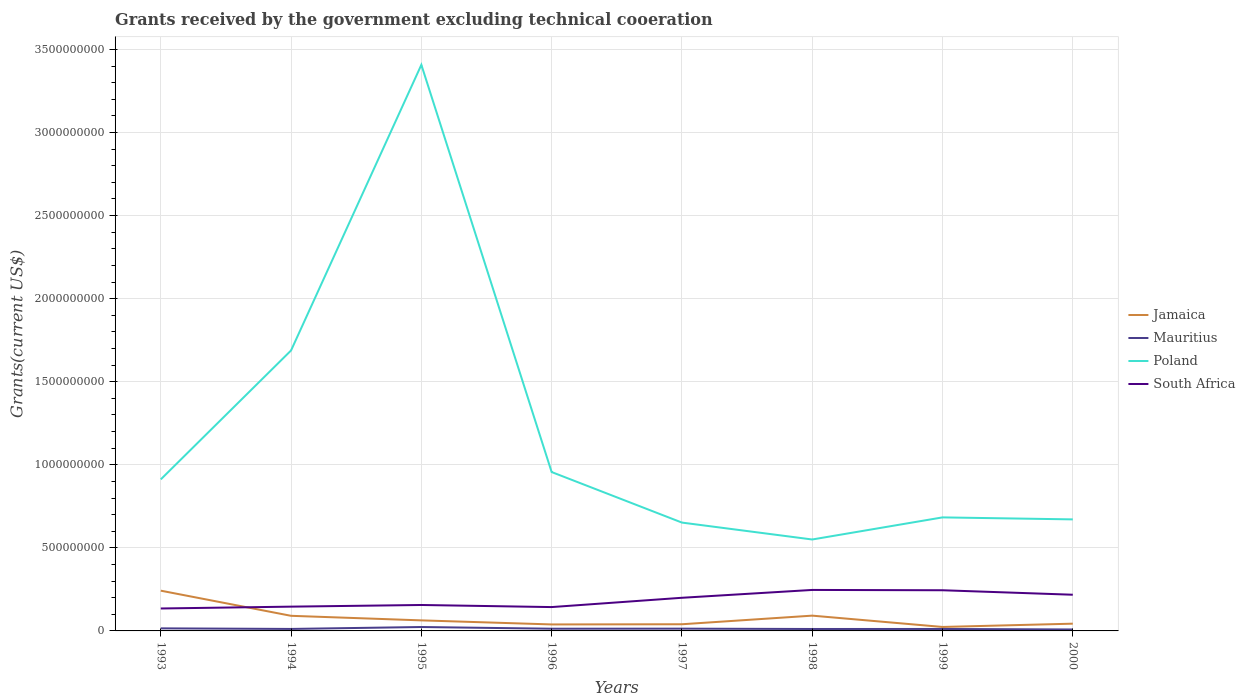How many different coloured lines are there?
Your answer should be very brief. 4. Does the line corresponding to Jamaica intersect with the line corresponding to South Africa?
Offer a very short reply. Yes. Is the number of lines equal to the number of legend labels?
Ensure brevity in your answer.  Yes. Across all years, what is the maximum total grants received by the government in Poland?
Keep it short and to the point. 5.50e+08. In which year was the total grants received by the government in South Africa maximum?
Give a very brief answer. 1993. What is the total total grants received by the government in Poland in the graph?
Offer a very short reply. 2.45e+09. What is the difference between the highest and the second highest total grants received by the government in South Africa?
Ensure brevity in your answer.  1.12e+08. What is the difference between the highest and the lowest total grants received by the government in South Africa?
Your answer should be compact. 4. How many years are there in the graph?
Ensure brevity in your answer.  8. Does the graph contain grids?
Your response must be concise. Yes. Where does the legend appear in the graph?
Make the answer very short. Center right. How many legend labels are there?
Your answer should be compact. 4. How are the legend labels stacked?
Offer a terse response. Vertical. What is the title of the graph?
Your answer should be very brief. Grants received by the government excluding technical cooeration. Does "High income: OECD" appear as one of the legend labels in the graph?
Provide a short and direct response. No. What is the label or title of the X-axis?
Ensure brevity in your answer.  Years. What is the label or title of the Y-axis?
Provide a succinct answer. Grants(current US$). What is the Grants(current US$) of Jamaica in 1993?
Provide a succinct answer. 2.42e+08. What is the Grants(current US$) in Mauritius in 1993?
Ensure brevity in your answer.  1.54e+07. What is the Grants(current US$) in Poland in 1993?
Your response must be concise. 9.12e+08. What is the Grants(current US$) in South Africa in 1993?
Provide a short and direct response. 1.35e+08. What is the Grants(current US$) in Jamaica in 1994?
Keep it short and to the point. 9.09e+07. What is the Grants(current US$) in Mauritius in 1994?
Keep it short and to the point. 1.19e+07. What is the Grants(current US$) in Poland in 1994?
Provide a short and direct response. 1.69e+09. What is the Grants(current US$) in South Africa in 1994?
Your response must be concise. 1.46e+08. What is the Grants(current US$) in Jamaica in 1995?
Offer a terse response. 6.35e+07. What is the Grants(current US$) in Mauritius in 1995?
Provide a short and direct response. 2.35e+07. What is the Grants(current US$) of Poland in 1995?
Provide a short and direct response. 3.41e+09. What is the Grants(current US$) in South Africa in 1995?
Provide a short and direct response. 1.56e+08. What is the Grants(current US$) in Jamaica in 1996?
Keep it short and to the point. 3.90e+07. What is the Grants(current US$) in Mauritius in 1996?
Your answer should be compact. 1.32e+07. What is the Grants(current US$) in Poland in 1996?
Ensure brevity in your answer.  9.56e+08. What is the Grants(current US$) of South Africa in 1996?
Offer a very short reply. 1.44e+08. What is the Grants(current US$) of Jamaica in 1997?
Give a very brief answer. 4.02e+07. What is the Grants(current US$) of Mauritius in 1997?
Provide a short and direct response. 1.36e+07. What is the Grants(current US$) of Poland in 1997?
Your answer should be very brief. 6.52e+08. What is the Grants(current US$) of South Africa in 1997?
Provide a short and direct response. 2.00e+08. What is the Grants(current US$) of Jamaica in 1998?
Provide a short and direct response. 9.20e+07. What is the Grants(current US$) in Mauritius in 1998?
Give a very brief answer. 1.17e+07. What is the Grants(current US$) in Poland in 1998?
Ensure brevity in your answer.  5.50e+08. What is the Grants(current US$) in South Africa in 1998?
Ensure brevity in your answer.  2.47e+08. What is the Grants(current US$) in Jamaica in 1999?
Make the answer very short. 2.39e+07. What is the Grants(current US$) of Mauritius in 1999?
Offer a very short reply. 1.17e+07. What is the Grants(current US$) in Poland in 1999?
Ensure brevity in your answer.  6.83e+08. What is the Grants(current US$) of South Africa in 1999?
Your answer should be compact. 2.45e+08. What is the Grants(current US$) of Jamaica in 2000?
Provide a short and direct response. 4.36e+07. What is the Grants(current US$) in Mauritius in 2000?
Make the answer very short. 8.79e+06. What is the Grants(current US$) in Poland in 2000?
Your answer should be very brief. 6.71e+08. What is the Grants(current US$) of South Africa in 2000?
Your answer should be compact. 2.18e+08. Across all years, what is the maximum Grants(current US$) of Jamaica?
Your answer should be very brief. 2.42e+08. Across all years, what is the maximum Grants(current US$) of Mauritius?
Make the answer very short. 2.35e+07. Across all years, what is the maximum Grants(current US$) in Poland?
Keep it short and to the point. 3.41e+09. Across all years, what is the maximum Grants(current US$) of South Africa?
Give a very brief answer. 2.47e+08. Across all years, what is the minimum Grants(current US$) of Jamaica?
Provide a succinct answer. 2.39e+07. Across all years, what is the minimum Grants(current US$) of Mauritius?
Provide a succinct answer. 8.79e+06. Across all years, what is the minimum Grants(current US$) of Poland?
Keep it short and to the point. 5.50e+08. Across all years, what is the minimum Grants(current US$) in South Africa?
Make the answer very short. 1.35e+08. What is the total Grants(current US$) in Jamaica in the graph?
Give a very brief answer. 6.35e+08. What is the total Grants(current US$) in Mauritius in the graph?
Provide a succinct answer. 1.10e+08. What is the total Grants(current US$) in Poland in the graph?
Ensure brevity in your answer.  9.52e+09. What is the total Grants(current US$) of South Africa in the graph?
Offer a very short reply. 1.49e+09. What is the difference between the Grants(current US$) of Jamaica in 1993 and that in 1994?
Your response must be concise. 1.51e+08. What is the difference between the Grants(current US$) of Mauritius in 1993 and that in 1994?
Your response must be concise. 3.50e+06. What is the difference between the Grants(current US$) of Poland in 1993 and that in 1994?
Provide a short and direct response. -7.76e+08. What is the difference between the Grants(current US$) in South Africa in 1993 and that in 1994?
Give a very brief answer. -1.11e+07. What is the difference between the Grants(current US$) in Jamaica in 1993 and that in 1995?
Provide a short and direct response. 1.79e+08. What is the difference between the Grants(current US$) in Mauritius in 1993 and that in 1995?
Provide a short and direct response. -8.08e+06. What is the difference between the Grants(current US$) in Poland in 1993 and that in 1995?
Offer a terse response. -2.50e+09. What is the difference between the Grants(current US$) in South Africa in 1993 and that in 1995?
Offer a very short reply. -2.11e+07. What is the difference between the Grants(current US$) in Jamaica in 1993 and that in 1996?
Keep it short and to the point. 2.03e+08. What is the difference between the Grants(current US$) of Mauritius in 1993 and that in 1996?
Offer a very short reply. 2.20e+06. What is the difference between the Grants(current US$) in Poland in 1993 and that in 1996?
Provide a short and direct response. -4.42e+07. What is the difference between the Grants(current US$) of South Africa in 1993 and that in 1996?
Keep it short and to the point. -8.52e+06. What is the difference between the Grants(current US$) of Jamaica in 1993 and that in 1997?
Provide a succinct answer. 2.02e+08. What is the difference between the Grants(current US$) in Mauritius in 1993 and that in 1997?
Your answer should be compact. 1.81e+06. What is the difference between the Grants(current US$) of Poland in 1993 and that in 1997?
Provide a short and direct response. 2.60e+08. What is the difference between the Grants(current US$) of South Africa in 1993 and that in 1997?
Ensure brevity in your answer.  -6.45e+07. What is the difference between the Grants(current US$) of Jamaica in 1993 and that in 1998?
Offer a very short reply. 1.50e+08. What is the difference between the Grants(current US$) of Mauritius in 1993 and that in 1998?
Offer a very short reply. 3.74e+06. What is the difference between the Grants(current US$) in Poland in 1993 and that in 1998?
Ensure brevity in your answer.  3.62e+08. What is the difference between the Grants(current US$) of South Africa in 1993 and that in 1998?
Your answer should be compact. -1.12e+08. What is the difference between the Grants(current US$) in Jamaica in 1993 and that in 1999?
Give a very brief answer. 2.18e+08. What is the difference between the Grants(current US$) of Mauritius in 1993 and that in 1999?
Ensure brevity in your answer.  3.71e+06. What is the difference between the Grants(current US$) of Poland in 1993 and that in 1999?
Give a very brief answer. 2.29e+08. What is the difference between the Grants(current US$) of South Africa in 1993 and that in 1999?
Your answer should be very brief. -1.10e+08. What is the difference between the Grants(current US$) of Jamaica in 1993 and that in 2000?
Provide a short and direct response. 1.99e+08. What is the difference between the Grants(current US$) in Mauritius in 1993 and that in 2000?
Offer a terse response. 6.65e+06. What is the difference between the Grants(current US$) of Poland in 1993 and that in 2000?
Ensure brevity in your answer.  2.41e+08. What is the difference between the Grants(current US$) in South Africa in 1993 and that in 2000?
Offer a very short reply. -8.28e+07. What is the difference between the Grants(current US$) of Jamaica in 1994 and that in 1995?
Make the answer very short. 2.74e+07. What is the difference between the Grants(current US$) of Mauritius in 1994 and that in 1995?
Your answer should be very brief. -1.16e+07. What is the difference between the Grants(current US$) of Poland in 1994 and that in 1995?
Provide a short and direct response. -1.72e+09. What is the difference between the Grants(current US$) of South Africa in 1994 and that in 1995?
Provide a short and direct response. -9.99e+06. What is the difference between the Grants(current US$) in Jamaica in 1994 and that in 1996?
Your answer should be very brief. 5.20e+07. What is the difference between the Grants(current US$) in Mauritius in 1994 and that in 1996?
Give a very brief answer. -1.30e+06. What is the difference between the Grants(current US$) of Poland in 1994 and that in 1996?
Ensure brevity in your answer.  7.32e+08. What is the difference between the Grants(current US$) of South Africa in 1994 and that in 1996?
Provide a succinct answer. 2.61e+06. What is the difference between the Grants(current US$) of Jamaica in 1994 and that in 1997?
Give a very brief answer. 5.08e+07. What is the difference between the Grants(current US$) in Mauritius in 1994 and that in 1997?
Keep it short and to the point. -1.69e+06. What is the difference between the Grants(current US$) of Poland in 1994 and that in 1997?
Your answer should be compact. 1.04e+09. What is the difference between the Grants(current US$) in South Africa in 1994 and that in 1997?
Provide a short and direct response. -5.34e+07. What is the difference between the Grants(current US$) in Jamaica in 1994 and that in 1998?
Offer a very short reply. -1.02e+06. What is the difference between the Grants(current US$) of Poland in 1994 and that in 1998?
Your answer should be very brief. 1.14e+09. What is the difference between the Grants(current US$) of South Africa in 1994 and that in 1998?
Your answer should be very brief. -1.01e+08. What is the difference between the Grants(current US$) in Jamaica in 1994 and that in 1999?
Make the answer very short. 6.70e+07. What is the difference between the Grants(current US$) in Mauritius in 1994 and that in 1999?
Keep it short and to the point. 2.10e+05. What is the difference between the Grants(current US$) in Poland in 1994 and that in 1999?
Offer a terse response. 1.00e+09. What is the difference between the Grants(current US$) of South Africa in 1994 and that in 1999?
Offer a very short reply. -9.86e+07. What is the difference between the Grants(current US$) of Jamaica in 1994 and that in 2000?
Keep it short and to the point. 4.73e+07. What is the difference between the Grants(current US$) in Mauritius in 1994 and that in 2000?
Keep it short and to the point. 3.15e+06. What is the difference between the Grants(current US$) in Poland in 1994 and that in 2000?
Give a very brief answer. 1.02e+09. What is the difference between the Grants(current US$) in South Africa in 1994 and that in 2000?
Provide a succinct answer. -7.16e+07. What is the difference between the Grants(current US$) of Jamaica in 1995 and that in 1996?
Provide a succinct answer. 2.45e+07. What is the difference between the Grants(current US$) in Mauritius in 1995 and that in 1996?
Offer a terse response. 1.03e+07. What is the difference between the Grants(current US$) in Poland in 1995 and that in 1996?
Ensure brevity in your answer.  2.45e+09. What is the difference between the Grants(current US$) in South Africa in 1995 and that in 1996?
Provide a succinct answer. 1.26e+07. What is the difference between the Grants(current US$) in Jamaica in 1995 and that in 1997?
Give a very brief answer. 2.33e+07. What is the difference between the Grants(current US$) in Mauritius in 1995 and that in 1997?
Provide a succinct answer. 9.89e+06. What is the difference between the Grants(current US$) of Poland in 1995 and that in 1997?
Your response must be concise. 2.76e+09. What is the difference between the Grants(current US$) of South Africa in 1995 and that in 1997?
Your response must be concise. -4.34e+07. What is the difference between the Grants(current US$) of Jamaica in 1995 and that in 1998?
Provide a succinct answer. -2.84e+07. What is the difference between the Grants(current US$) of Mauritius in 1995 and that in 1998?
Provide a succinct answer. 1.18e+07. What is the difference between the Grants(current US$) of Poland in 1995 and that in 1998?
Your response must be concise. 2.86e+09. What is the difference between the Grants(current US$) of South Africa in 1995 and that in 1998?
Make the answer very short. -9.06e+07. What is the difference between the Grants(current US$) of Jamaica in 1995 and that in 1999?
Give a very brief answer. 3.96e+07. What is the difference between the Grants(current US$) in Mauritius in 1995 and that in 1999?
Offer a terse response. 1.18e+07. What is the difference between the Grants(current US$) in Poland in 1995 and that in 1999?
Your answer should be very brief. 2.72e+09. What is the difference between the Grants(current US$) in South Africa in 1995 and that in 1999?
Offer a terse response. -8.87e+07. What is the difference between the Grants(current US$) in Jamaica in 1995 and that in 2000?
Your answer should be compact. 1.99e+07. What is the difference between the Grants(current US$) in Mauritius in 1995 and that in 2000?
Provide a short and direct response. 1.47e+07. What is the difference between the Grants(current US$) of Poland in 1995 and that in 2000?
Make the answer very short. 2.74e+09. What is the difference between the Grants(current US$) in South Africa in 1995 and that in 2000?
Keep it short and to the point. -6.16e+07. What is the difference between the Grants(current US$) in Jamaica in 1996 and that in 1997?
Your answer should be very brief. -1.18e+06. What is the difference between the Grants(current US$) of Mauritius in 1996 and that in 1997?
Offer a very short reply. -3.90e+05. What is the difference between the Grants(current US$) in Poland in 1996 and that in 1997?
Keep it short and to the point. 3.04e+08. What is the difference between the Grants(current US$) of South Africa in 1996 and that in 1997?
Offer a terse response. -5.60e+07. What is the difference between the Grants(current US$) in Jamaica in 1996 and that in 1998?
Provide a succinct answer. -5.30e+07. What is the difference between the Grants(current US$) of Mauritius in 1996 and that in 1998?
Offer a terse response. 1.54e+06. What is the difference between the Grants(current US$) of Poland in 1996 and that in 1998?
Your answer should be compact. 4.06e+08. What is the difference between the Grants(current US$) in South Africa in 1996 and that in 1998?
Your response must be concise. -1.03e+08. What is the difference between the Grants(current US$) in Jamaica in 1996 and that in 1999?
Offer a terse response. 1.51e+07. What is the difference between the Grants(current US$) of Mauritius in 1996 and that in 1999?
Provide a short and direct response. 1.51e+06. What is the difference between the Grants(current US$) in Poland in 1996 and that in 1999?
Make the answer very short. 2.73e+08. What is the difference between the Grants(current US$) of South Africa in 1996 and that in 1999?
Provide a succinct answer. -1.01e+08. What is the difference between the Grants(current US$) of Jamaica in 1996 and that in 2000?
Make the answer very short. -4.63e+06. What is the difference between the Grants(current US$) of Mauritius in 1996 and that in 2000?
Offer a very short reply. 4.45e+06. What is the difference between the Grants(current US$) of Poland in 1996 and that in 2000?
Your response must be concise. 2.85e+08. What is the difference between the Grants(current US$) in South Africa in 1996 and that in 2000?
Make the answer very short. -7.42e+07. What is the difference between the Grants(current US$) of Jamaica in 1997 and that in 1998?
Your response must be concise. -5.18e+07. What is the difference between the Grants(current US$) of Mauritius in 1997 and that in 1998?
Provide a succinct answer. 1.93e+06. What is the difference between the Grants(current US$) in Poland in 1997 and that in 1998?
Offer a terse response. 1.02e+08. What is the difference between the Grants(current US$) in South Africa in 1997 and that in 1998?
Your response must be concise. -4.72e+07. What is the difference between the Grants(current US$) of Jamaica in 1997 and that in 1999?
Give a very brief answer. 1.63e+07. What is the difference between the Grants(current US$) of Mauritius in 1997 and that in 1999?
Offer a very short reply. 1.90e+06. What is the difference between the Grants(current US$) in Poland in 1997 and that in 1999?
Your response must be concise. -3.12e+07. What is the difference between the Grants(current US$) of South Africa in 1997 and that in 1999?
Ensure brevity in your answer.  -4.53e+07. What is the difference between the Grants(current US$) in Jamaica in 1997 and that in 2000?
Your answer should be compact. -3.45e+06. What is the difference between the Grants(current US$) of Mauritius in 1997 and that in 2000?
Your answer should be compact. 4.84e+06. What is the difference between the Grants(current US$) of Poland in 1997 and that in 2000?
Provide a short and direct response. -1.92e+07. What is the difference between the Grants(current US$) of South Africa in 1997 and that in 2000?
Your answer should be very brief. -1.83e+07. What is the difference between the Grants(current US$) of Jamaica in 1998 and that in 1999?
Ensure brevity in your answer.  6.80e+07. What is the difference between the Grants(current US$) in Poland in 1998 and that in 1999?
Offer a very short reply. -1.33e+08. What is the difference between the Grants(current US$) of South Africa in 1998 and that in 1999?
Make the answer very short. 1.90e+06. What is the difference between the Grants(current US$) in Jamaica in 1998 and that in 2000?
Your answer should be very brief. 4.83e+07. What is the difference between the Grants(current US$) of Mauritius in 1998 and that in 2000?
Keep it short and to the point. 2.91e+06. What is the difference between the Grants(current US$) in Poland in 1998 and that in 2000?
Your response must be concise. -1.21e+08. What is the difference between the Grants(current US$) of South Africa in 1998 and that in 2000?
Your answer should be very brief. 2.89e+07. What is the difference between the Grants(current US$) of Jamaica in 1999 and that in 2000?
Keep it short and to the point. -1.97e+07. What is the difference between the Grants(current US$) in Mauritius in 1999 and that in 2000?
Offer a very short reply. 2.94e+06. What is the difference between the Grants(current US$) in South Africa in 1999 and that in 2000?
Offer a terse response. 2.70e+07. What is the difference between the Grants(current US$) in Jamaica in 1993 and the Grants(current US$) in Mauritius in 1994?
Ensure brevity in your answer.  2.30e+08. What is the difference between the Grants(current US$) in Jamaica in 1993 and the Grants(current US$) in Poland in 1994?
Make the answer very short. -1.45e+09. What is the difference between the Grants(current US$) in Jamaica in 1993 and the Grants(current US$) in South Africa in 1994?
Make the answer very short. 9.61e+07. What is the difference between the Grants(current US$) in Mauritius in 1993 and the Grants(current US$) in Poland in 1994?
Provide a succinct answer. -1.67e+09. What is the difference between the Grants(current US$) in Mauritius in 1993 and the Grants(current US$) in South Africa in 1994?
Your answer should be compact. -1.31e+08. What is the difference between the Grants(current US$) of Poland in 1993 and the Grants(current US$) of South Africa in 1994?
Your answer should be very brief. 7.66e+08. What is the difference between the Grants(current US$) of Jamaica in 1993 and the Grants(current US$) of Mauritius in 1995?
Your answer should be very brief. 2.19e+08. What is the difference between the Grants(current US$) in Jamaica in 1993 and the Grants(current US$) in Poland in 1995?
Your answer should be very brief. -3.17e+09. What is the difference between the Grants(current US$) of Jamaica in 1993 and the Grants(current US$) of South Africa in 1995?
Give a very brief answer. 8.61e+07. What is the difference between the Grants(current US$) in Mauritius in 1993 and the Grants(current US$) in Poland in 1995?
Keep it short and to the point. -3.39e+09. What is the difference between the Grants(current US$) in Mauritius in 1993 and the Grants(current US$) in South Africa in 1995?
Your response must be concise. -1.41e+08. What is the difference between the Grants(current US$) in Poland in 1993 and the Grants(current US$) in South Africa in 1995?
Make the answer very short. 7.56e+08. What is the difference between the Grants(current US$) of Jamaica in 1993 and the Grants(current US$) of Mauritius in 1996?
Your response must be concise. 2.29e+08. What is the difference between the Grants(current US$) in Jamaica in 1993 and the Grants(current US$) in Poland in 1996?
Give a very brief answer. -7.14e+08. What is the difference between the Grants(current US$) in Jamaica in 1993 and the Grants(current US$) in South Africa in 1996?
Offer a terse response. 9.87e+07. What is the difference between the Grants(current US$) of Mauritius in 1993 and the Grants(current US$) of Poland in 1996?
Your answer should be compact. -9.41e+08. What is the difference between the Grants(current US$) of Mauritius in 1993 and the Grants(current US$) of South Africa in 1996?
Offer a terse response. -1.28e+08. What is the difference between the Grants(current US$) in Poland in 1993 and the Grants(current US$) in South Africa in 1996?
Keep it short and to the point. 7.69e+08. What is the difference between the Grants(current US$) of Jamaica in 1993 and the Grants(current US$) of Mauritius in 1997?
Offer a terse response. 2.29e+08. What is the difference between the Grants(current US$) of Jamaica in 1993 and the Grants(current US$) of Poland in 1997?
Make the answer very short. -4.10e+08. What is the difference between the Grants(current US$) in Jamaica in 1993 and the Grants(current US$) in South Africa in 1997?
Keep it short and to the point. 4.28e+07. What is the difference between the Grants(current US$) in Mauritius in 1993 and the Grants(current US$) in Poland in 1997?
Ensure brevity in your answer.  -6.37e+08. What is the difference between the Grants(current US$) in Mauritius in 1993 and the Grants(current US$) in South Africa in 1997?
Give a very brief answer. -1.84e+08. What is the difference between the Grants(current US$) in Poland in 1993 and the Grants(current US$) in South Africa in 1997?
Provide a succinct answer. 7.13e+08. What is the difference between the Grants(current US$) in Jamaica in 1993 and the Grants(current US$) in Mauritius in 1998?
Provide a succinct answer. 2.31e+08. What is the difference between the Grants(current US$) of Jamaica in 1993 and the Grants(current US$) of Poland in 1998?
Your answer should be very brief. -3.08e+08. What is the difference between the Grants(current US$) of Jamaica in 1993 and the Grants(current US$) of South Africa in 1998?
Provide a succinct answer. -4.42e+06. What is the difference between the Grants(current US$) in Mauritius in 1993 and the Grants(current US$) in Poland in 1998?
Give a very brief answer. -5.35e+08. What is the difference between the Grants(current US$) in Mauritius in 1993 and the Grants(current US$) in South Africa in 1998?
Offer a terse response. -2.31e+08. What is the difference between the Grants(current US$) of Poland in 1993 and the Grants(current US$) of South Africa in 1998?
Make the answer very short. 6.65e+08. What is the difference between the Grants(current US$) of Jamaica in 1993 and the Grants(current US$) of Mauritius in 1999?
Make the answer very short. 2.31e+08. What is the difference between the Grants(current US$) of Jamaica in 1993 and the Grants(current US$) of Poland in 1999?
Your response must be concise. -4.41e+08. What is the difference between the Grants(current US$) of Jamaica in 1993 and the Grants(current US$) of South Africa in 1999?
Your response must be concise. -2.52e+06. What is the difference between the Grants(current US$) in Mauritius in 1993 and the Grants(current US$) in Poland in 1999?
Offer a terse response. -6.68e+08. What is the difference between the Grants(current US$) in Mauritius in 1993 and the Grants(current US$) in South Africa in 1999?
Ensure brevity in your answer.  -2.29e+08. What is the difference between the Grants(current US$) of Poland in 1993 and the Grants(current US$) of South Africa in 1999?
Offer a terse response. 6.67e+08. What is the difference between the Grants(current US$) in Jamaica in 1993 and the Grants(current US$) in Mauritius in 2000?
Ensure brevity in your answer.  2.34e+08. What is the difference between the Grants(current US$) of Jamaica in 1993 and the Grants(current US$) of Poland in 2000?
Offer a very short reply. -4.29e+08. What is the difference between the Grants(current US$) of Jamaica in 1993 and the Grants(current US$) of South Africa in 2000?
Keep it short and to the point. 2.45e+07. What is the difference between the Grants(current US$) of Mauritius in 1993 and the Grants(current US$) of Poland in 2000?
Your answer should be very brief. -6.56e+08. What is the difference between the Grants(current US$) in Mauritius in 1993 and the Grants(current US$) in South Africa in 2000?
Your answer should be very brief. -2.02e+08. What is the difference between the Grants(current US$) of Poland in 1993 and the Grants(current US$) of South Africa in 2000?
Keep it short and to the point. 6.94e+08. What is the difference between the Grants(current US$) of Jamaica in 1994 and the Grants(current US$) of Mauritius in 1995?
Provide a short and direct response. 6.74e+07. What is the difference between the Grants(current US$) of Jamaica in 1994 and the Grants(current US$) of Poland in 1995?
Your answer should be very brief. -3.32e+09. What is the difference between the Grants(current US$) of Jamaica in 1994 and the Grants(current US$) of South Africa in 1995?
Keep it short and to the point. -6.52e+07. What is the difference between the Grants(current US$) of Mauritius in 1994 and the Grants(current US$) of Poland in 1995?
Ensure brevity in your answer.  -3.40e+09. What is the difference between the Grants(current US$) in Mauritius in 1994 and the Grants(current US$) in South Africa in 1995?
Your response must be concise. -1.44e+08. What is the difference between the Grants(current US$) in Poland in 1994 and the Grants(current US$) in South Africa in 1995?
Make the answer very short. 1.53e+09. What is the difference between the Grants(current US$) of Jamaica in 1994 and the Grants(current US$) of Mauritius in 1996?
Provide a short and direct response. 7.77e+07. What is the difference between the Grants(current US$) in Jamaica in 1994 and the Grants(current US$) in Poland in 1996?
Your response must be concise. -8.65e+08. What is the difference between the Grants(current US$) in Jamaica in 1994 and the Grants(current US$) in South Africa in 1996?
Keep it short and to the point. -5.26e+07. What is the difference between the Grants(current US$) in Mauritius in 1994 and the Grants(current US$) in Poland in 1996?
Make the answer very short. -9.44e+08. What is the difference between the Grants(current US$) in Mauritius in 1994 and the Grants(current US$) in South Africa in 1996?
Your answer should be very brief. -1.32e+08. What is the difference between the Grants(current US$) in Poland in 1994 and the Grants(current US$) in South Africa in 1996?
Your response must be concise. 1.54e+09. What is the difference between the Grants(current US$) in Jamaica in 1994 and the Grants(current US$) in Mauritius in 1997?
Offer a very short reply. 7.73e+07. What is the difference between the Grants(current US$) in Jamaica in 1994 and the Grants(current US$) in Poland in 1997?
Keep it short and to the point. -5.61e+08. What is the difference between the Grants(current US$) in Jamaica in 1994 and the Grants(current US$) in South Africa in 1997?
Offer a terse response. -1.09e+08. What is the difference between the Grants(current US$) of Mauritius in 1994 and the Grants(current US$) of Poland in 1997?
Give a very brief answer. -6.40e+08. What is the difference between the Grants(current US$) in Mauritius in 1994 and the Grants(current US$) in South Africa in 1997?
Offer a very short reply. -1.88e+08. What is the difference between the Grants(current US$) of Poland in 1994 and the Grants(current US$) of South Africa in 1997?
Your answer should be very brief. 1.49e+09. What is the difference between the Grants(current US$) of Jamaica in 1994 and the Grants(current US$) of Mauritius in 1998?
Your response must be concise. 7.92e+07. What is the difference between the Grants(current US$) in Jamaica in 1994 and the Grants(current US$) in Poland in 1998?
Your answer should be compact. -4.59e+08. What is the difference between the Grants(current US$) in Jamaica in 1994 and the Grants(current US$) in South Africa in 1998?
Your answer should be very brief. -1.56e+08. What is the difference between the Grants(current US$) of Mauritius in 1994 and the Grants(current US$) of Poland in 1998?
Keep it short and to the point. -5.38e+08. What is the difference between the Grants(current US$) of Mauritius in 1994 and the Grants(current US$) of South Africa in 1998?
Ensure brevity in your answer.  -2.35e+08. What is the difference between the Grants(current US$) of Poland in 1994 and the Grants(current US$) of South Africa in 1998?
Provide a short and direct response. 1.44e+09. What is the difference between the Grants(current US$) of Jamaica in 1994 and the Grants(current US$) of Mauritius in 1999?
Ensure brevity in your answer.  7.92e+07. What is the difference between the Grants(current US$) in Jamaica in 1994 and the Grants(current US$) in Poland in 1999?
Your answer should be compact. -5.92e+08. What is the difference between the Grants(current US$) in Jamaica in 1994 and the Grants(current US$) in South Africa in 1999?
Offer a very short reply. -1.54e+08. What is the difference between the Grants(current US$) of Mauritius in 1994 and the Grants(current US$) of Poland in 1999?
Your answer should be very brief. -6.71e+08. What is the difference between the Grants(current US$) of Mauritius in 1994 and the Grants(current US$) of South Africa in 1999?
Give a very brief answer. -2.33e+08. What is the difference between the Grants(current US$) in Poland in 1994 and the Grants(current US$) in South Africa in 1999?
Provide a short and direct response. 1.44e+09. What is the difference between the Grants(current US$) in Jamaica in 1994 and the Grants(current US$) in Mauritius in 2000?
Offer a very short reply. 8.22e+07. What is the difference between the Grants(current US$) of Jamaica in 1994 and the Grants(current US$) of Poland in 2000?
Ensure brevity in your answer.  -5.80e+08. What is the difference between the Grants(current US$) in Jamaica in 1994 and the Grants(current US$) in South Africa in 2000?
Make the answer very short. -1.27e+08. What is the difference between the Grants(current US$) in Mauritius in 1994 and the Grants(current US$) in Poland in 2000?
Provide a short and direct response. -6.59e+08. What is the difference between the Grants(current US$) in Mauritius in 1994 and the Grants(current US$) in South Africa in 2000?
Make the answer very short. -2.06e+08. What is the difference between the Grants(current US$) in Poland in 1994 and the Grants(current US$) in South Africa in 2000?
Offer a very short reply. 1.47e+09. What is the difference between the Grants(current US$) in Jamaica in 1995 and the Grants(current US$) in Mauritius in 1996?
Offer a terse response. 5.03e+07. What is the difference between the Grants(current US$) in Jamaica in 1995 and the Grants(current US$) in Poland in 1996?
Make the answer very short. -8.93e+08. What is the difference between the Grants(current US$) in Jamaica in 1995 and the Grants(current US$) in South Africa in 1996?
Your response must be concise. -8.00e+07. What is the difference between the Grants(current US$) in Mauritius in 1995 and the Grants(current US$) in Poland in 1996?
Offer a terse response. -9.33e+08. What is the difference between the Grants(current US$) in Mauritius in 1995 and the Grants(current US$) in South Africa in 1996?
Offer a very short reply. -1.20e+08. What is the difference between the Grants(current US$) in Poland in 1995 and the Grants(current US$) in South Africa in 1996?
Your answer should be compact. 3.26e+09. What is the difference between the Grants(current US$) of Jamaica in 1995 and the Grants(current US$) of Mauritius in 1997?
Make the answer very short. 4.99e+07. What is the difference between the Grants(current US$) of Jamaica in 1995 and the Grants(current US$) of Poland in 1997?
Make the answer very short. -5.89e+08. What is the difference between the Grants(current US$) of Jamaica in 1995 and the Grants(current US$) of South Africa in 1997?
Offer a very short reply. -1.36e+08. What is the difference between the Grants(current US$) of Mauritius in 1995 and the Grants(current US$) of Poland in 1997?
Provide a succinct answer. -6.29e+08. What is the difference between the Grants(current US$) of Mauritius in 1995 and the Grants(current US$) of South Africa in 1997?
Ensure brevity in your answer.  -1.76e+08. What is the difference between the Grants(current US$) in Poland in 1995 and the Grants(current US$) in South Africa in 1997?
Your answer should be compact. 3.21e+09. What is the difference between the Grants(current US$) in Jamaica in 1995 and the Grants(current US$) in Mauritius in 1998?
Offer a terse response. 5.18e+07. What is the difference between the Grants(current US$) in Jamaica in 1995 and the Grants(current US$) in Poland in 1998?
Your response must be concise. -4.87e+08. What is the difference between the Grants(current US$) in Jamaica in 1995 and the Grants(current US$) in South Africa in 1998?
Ensure brevity in your answer.  -1.83e+08. What is the difference between the Grants(current US$) of Mauritius in 1995 and the Grants(current US$) of Poland in 1998?
Your answer should be compact. -5.27e+08. What is the difference between the Grants(current US$) of Mauritius in 1995 and the Grants(current US$) of South Africa in 1998?
Your response must be concise. -2.23e+08. What is the difference between the Grants(current US$) of Poland in 1995 and the Grants(current US$) of South Africa in 1998?
Keep it short and to the point. 3.16e+09. What is the difference between the Grants(current US$) in Jamaica in 1995 and the Grants(current US$) in Mauritius in 1999?
Your answer should be compact. 5.18e+07. What is the difference between the Grants(current US$) of Jamaica in 1995 and the Grants(current US$) of Poland in 1999?
Offer a very short reply. -6.20e+08. What is the difference between the Grants(current US$) of Jamaica in 1995 and the Grants(current US$) of South Africa in 1999?
Provide a succinct answer. -1.81e+08. What is the difference between the Grants(current US$) in Mauritius in 1995 and the Grants(current US$) in Poland in 1999?
Offer a very short reply. -6.60e+08. What is the difference between the Grants(current US$) of Mauritius in 1995 and the Grants(current US$) of South Africa in 1999?
Offer a terse response. -2.21e+08. What is the difference between the Grants(current US$) of Poland in 1995 and the Grants(current US$) of South Africa in 1999?
Ensure brevity in your answer.  3.16e+09. What is the difference between the Grants(current US$) in Jamaica in 1995 and the Grants(current US$) in Mauritius in 2000?
Make the answer very short. 5.47e+07. What is the difference between the Grants(current US$) of Jamaica in 1995 and the Grants(current US$) of Poland in 2000?
Your response must be concise. -6.08e+08. What is the difference between the Grants(current US$) in Jamaica in 1995 and the Grants(current US$) in South Africa in 2000?
Make the answer very short. -1.54e+08. What is the difference between the Grants(current US$) in Mauritius in 1995 and the Grants(current US$) in Poland in 2000?
Provide a succinct answer. -6.48e+08. What is the difference between the Grants(current US$) in Mauritius in 1995 and the Grants(current US$) in South Africa in 2000?
Your answer should be compact. -1.94e+08. What is the difference between the Grants(current US$) in Poland in 1995 and the Grants(current US$) in South Africa in 2000?
Ensure brevity in your answer.  3.19e+09. What is the difference between the Grants(current US$) of Jamaica in 1996 and the Grants(current US$) of Mauritius in 1997?
Offer a terse response. 2.54e+07. What is the difference between the Grants(current US$) of Jamaica in 1996 and the Grants(current US$) of Poland in 1997?
Your answer should be very brief. -6.13e+08. What is the difference between the Grants(current US$) of Jamaica in 1996 and the Grants(current US$) of South Africa in 1997?
Your answer should be very brief. -1.61e+08. What is the difference between the Grants(current US$) in Mauritius in 1996 and the Grants(current US$) in Poland in 1997?
Give a very brief answer. -6.39e+08. What is the difference between the Grants(current US$) in Mauritius in 1996 and the Grants(current US$) in South Africa in 1997?
Your answer should be compact. -1.86e+08. What is the difference between the Grants(current US$) of Poland in 1996 and the Grants(current US$) of South Africa in 1997?
Your answer should be very brief. 7.57e+08. What is the difference between the Grants(current US$) of Jamaica in 1996 and the Grants(current US$) of Mauritius in 1998?
Provide a short and direct response. 2.73e+07. What is the difference between the Grants(current US$) of Jamaica in 1996 and the Grants(current US$) of Poland in 1998?
Keep it short and to the point. -5.11e+08. What is the difference between the Grants(current US$) of Jamaica in 1996 and the Grants(current US$) of South Africa in 1998?
Offer a very short reply. -2.08e+08. What is the difference between the Grants(current US$) in Mauritius in 1996 and the Grants(current US$) in Poland in 1998?
Give a very brief answer. -5.37e+08. What is the difference between the Grants(current US$) in Mauritius in 1996 and the Grants(current US$) in South Africa in 1998?
Provide a short and direct response. -2.33e+08. What is the difference between the Grants(current US$) of Poland in 1996 and the Grants(current US$) of South Africa in 1998?
Give a very brief answer. 7.10e+08. What is the difference between the Grants(current US$) in Jamaica in 1996 and the Grants(current US$) in Mauritius in 1999?
Your answer should be very brief. 2.73e+07. What is the difference between the Grants(current US$) in Jamaica in 1996 and the Grants(current US$) in Poland in 1999?
Offer a terse response. -6.44e+08. What is the difference between the Grants(current US$) in Jamaica in 1996 and the Grants(current US$) in South Africa in 1999?
Your response must be concise. -2.06e+08. What is the difference between the Grants(current US$) in Mauritius in 1996 and the Grants(current US$) in Poland in 1999?
Offer a terse response. -6.70e+08. What is the difference between the Grants(current US$) of Mauritius in 1996 and the Grants(current US$) of South Africa in 1999?
Offer a very short reply. -2.32e+08. What is the difference between the Grants(current US$) of Poland in 1996 and the Grants(current US$) of South Africa in 1999?
Your response must be concise. 7.12e+08. What is the difference between the Grants(current US$) of Jamaica in 1996 and the Grants(current US$) of Mauritius in 2000?
Your answer should be very brief. 3.02e+07. What is the difference between the Grants(current US$) of Jamaica in 1996 and the Grants(current US$) of Poland in 2000?
Your response must be concise. -6.32e+08. What is the difference between the Grants(current US$) of Jamaica in 1996 and the Grants(current US$) of South Africa in 2000?
Make the answer very short. -1.79e+08. What is the difference between the Grants(current US$) in Mauritius in 1996 and the Grants(current US$) in Poland in 2000?
Make the answer very short. -6.58e+08. What is the difference between the Grants(current US$) of Mauritius in 1996 and the Grants(current US$) of South Africa in 2000?
Your response must be concise. -2.05e+08. What is the difference between the Grants(current US$) of Poland in 1996 and the Grants(current US$) of South Africa in 2000?
Your answer should be very brief. 7.39e+08. What is the difference between the Grants(current US$) in Jamaica in 1997 and the Grants(current US$) in Mauritius in 1998?
Provide a succinct answer. 2.85e+07. What is the difference between the Grants(current US$) of Jamaica in 1997 and the Grants(current US$) of Poland in 1998?
Provide a succinct answer. -5.10e+08. What is the difference between the Grants(current US$) of Jamaica in 1997 and the Grants(current US$) of South Africa in 1998?
Keep it short and to the point. -2.07e+08. What is the difference between the Grants(current US$) of Mauritius in 1997 and the Grants(current US$) of Poland in 1998?
Give a very brief answer. -5.37e+08. What is the difference between the Grants(current US$) in Mauritius in 1997 and the Grants(current US$) in South Africa in 1998?
Make the answer very short. -2.33e+08. What is the difference between the Grants(current US$) in Poland in 1997 and the Grants(current US$) in South Africa in 1998?
Your answer should be very brief. 4.05e+08. What is the difference between the Grants(current US$) in Jamaica in 1997 and the Grants(current US$) in Mauritius in 1999?
Make the answer very short. 2.84e+07. What is the difference between the Grants(current US$) of Jamaica in 1997 and the Grants(current US$) of Poland in 1999?
Ensure brevity in your answer.  -6.43e+08. What is the difference between the Grants(current US$) in Jamaica in 1997 and the Grants(current US$) in South Africa in 1999?
Offer a terse response. -2.05e+08. What is the difference between the Grants(current US$) in Mauritius in 1997 and the Grants(current US$) in Poland in 1999?
Your response must be concise. -6.70e+08. What is the difference between the Grants(current US$) in Mauritius in 1997 and the Grants(current US$) in South Africa in 1999?
Your response must be concise. -2.31e+08. What is the difference between the Grants(current US$) in Poland in 1997 and the Grants(current US$) in South Africa in 1999?
Keep it short and to the point. 4.07e+08. What is the difference between the Grants(current US$) of Jamaica in 1997 and the Grants(current US$) of Mauritius in 2000?
Give a very brief answer. 3.14e+07. What is the difference between the Grants(current US$) of Jamaica in 1997 and the Grants(current US$) of Poland in 2000?
Ensure brevity in your answer.  -6.31e+08. What is the difference between the Grants(current US$) in Jamaica in 1997 and the Grants(current US$) in South Africa in 2000?
Your response must be concise. -1.78e+08. What is the difference between the Grants(current US$) in Mauritius in 1997 and the Grants(current US$) in Poland in 2000?
Ensure brevity in your answer.  -6.58e+08. What is the difference between the Grants(current US$) in Mauritius in 1997 and the Grants(current US$) in South Africa in 2000?
Your answer should be very brief. -2.04e+08. What is the difference between the Grants(current US$) of Poland in 1997 and the Grants(current US$) of South Africa in 2000?
Your answer should be compact. 4.34e+08. What is the difference between the Grants(current US$) of Jamaica in 1998 and the Grants(current US$) of Mauritius in 1999?
Provide a short and direct response. 8.02e+07. What is the difference between the Grants(current US$) in Jamaica in 1998 and the Grants(current US$) in Poland in 1999?
Offer a terse response. -5.91e+08. What is the difference between the Grants(current US$) of Jamaica in 1998 and the Grants(current US$) of South Africa in 1999?
Provide a succinct answer. -1.53e+08. What is the difference between the Grants(current US$) of Mauritius in 1998 and the Grants(current US$) of Poland in 1999?
Make the answer very short. -6.72e+08. What is the difference between the Grants(current US$) in Mauritius in 1998 and the Grants(current US$) in South Africa in 1999?
Your response must be concise. -2.33e+08. What is the difference between the Grants(current US$) in Poland in 1998 and the Grants(current US$) in South Africa in 1999?
Ensure brevity in your answer.  3.06e+08. What is the difference between the Grants(current US$) of Jamaica in 1998 and the Grants(current US$) of Mauritius in 2000?
Offer a terse response. 8.32e+07. What is the difference between the Grants(current US$) of Jamaica in 1998 and the Grants(current US$) of Poland in 2000?
Your answer should be compact. -5.79e+08. What is the difference between the Grants(current US$) in Jamaica in 1998 and the Grants(current US$) in South Africa in 2000?
Make the answer very short. -1.26e+08. What is the difference between the Grants(current US$) of Mauritius in 1998 and the Grants(current US$) of Poland in 2000?
Provide a succinct answer. -6.60e+08. What is the difference between the Grants(current US$) in Mauritius in 1998 and the Grants(current US$) in South Africa in 2000?
Keep it short and to the point. -2.06e+08. What is the difference between the Grants(current US$) of Poland in 1998 and the Grants(current US$) of South Africa in 2000?
Offer a terse response. 3.33e+08. What is the difference between the Grants(current US$) in Jamaica in 1999 and the Grants(current US$) in Mauritius in 2000?
Offer a very short reply. 1.51e+07. What is the difference between the Grants(current US$) in Jamaica in 1999 and the Grants(current US$) in Poland in 2000?
Your answer should be compact. -6.47e+08. What is the difference between the Grants(current US$) in Jamaica in 1999 and the Grants(current US$) in South Africa in 2000?
Your response must be concise. -1.94e+08. What is the difference between the Grants(current US$) of Mauritius in 1999 and the Grants(current US$) of Poland in 2000?
Provide a short and direct response. -6.60e+08. What is the difference between the Grants(current US$) of Mauritius in 1999 and the Grants(current US$) of South Africa in 2000?
Give a very brief answer. -2.06e+08. What is the difference between the Grants(current US$) in Poland in 1999 and the Grants(current US$) in South Africa in 2000?
Make the answer very short. 4.66e+08. What is the average Grants(current US$) of Jamaica per year?
Ensure brevity in your answer.  7.94e+07. What is the average Grants(current US$) of Mauritius per year?
Offer a terse response. 1.37e+07. What is the average Grants(current US$) in Poland per year?
Make the answer very short. 1.19e+09. What is the average Grants(current US$) in South Africa per year?
Keep it short and to the point. 1.86e+08. In the year 1993, what is the difference between the Grants(current US$) in Jamaica and Grants(current US$) in Mauritius?
Provide a succinct answer. 2.27e+08. In the year 1993, what is the difference between the Grants(current US$) of Jamaica and Grants(current US$) of Poland?
Your answer should be compact. -6.70e+08. In the year 1993, what is the difference between the Grants(current US$) of Jamaica and Grants(current US$) of South Africa?
Your answer should be very brief. 1.07e+08. In the year 1993, what is the difference between the Grants(current US$) in Mauritius and Grants(current US$) in Poland?
Keep it short and to the point. -8.97e+08. In the year 1993, what is the difference between the Grants(current US$) in Mauritius and Grants(current US$) in South Africa?
Make the answer very short. -1.20e+08. In the year 1993, what is the difference between the Grants(current US$) in Poland and Grants(current US$) in South Africa?
Make the answer very short. 7.77e+08. In the year 1994, what is the difference between the Grants(current US$) in Jamaica and Grants(current US$) in Mauritius?
Offer a terse response. 7.90e+07. In the year 1994, what is the difference between the Grants(current US$) in Jamaica and Grants(current US$) in Poland?
Ensure brevity in your answer.  -1.60e+09. In the year 1994, what is the difference between the Grants(current US$) of Jamaica and Grants(current US$) of South Africa?
Your answer should be compact. -5.52e+07. In the year 1994, what is the difference between the Grants(current US$) of Mauritius and Grants(current US$) of Poland?
Your answer should be compact. -1.68e+09. In the year 1994, what is the difference between the Grants(current US$) of Mauritius and Grants(current US$) of South Africa?
Make the answer very short. -1.34e+08. In the year 1994, what is the difference between the Grants(current US$) of Poland and Grants(current US$) of South Africa?
Keep it short and to the point. 1.54e+09. In the year 1995, what is the difference between the Grants(current US$) in Jamaica and Grants(current US$) in Mauritius?
Keep it short and to the point. 4.00e+07. In the year 1995, what is the difference between the Grants(current US$) of Jamaica and Grants(current US$) of Poland?
Your response must be concise. -3.34e+09. In the year 1995, what is the difference between the Grants(current US$) in Jamaica and Grants(current US$) in South Africa?
Ensure brevity in your answer.  -9.26e+07. In the year 1995, what is the difference between the Grants(current US$) of Mauritius and Grants(current US$) of Poland?
Keep it short and to the point. -3.38e+09. In the year 1995, what is the difference between the Grants(current US$) of Mauritius and Grants(current US$) of South Africa?
Offer a very short reply. -1.33e+08. In the year 1995, what is the difference between the Grants(current US$) of Poland and Grants(current US$) of South Africa?
Provide a short and direct response. 3.25e+09. In the year 1996, what is the difference between the Grants(current US$) in Jamaica and Grants(current US$) in Mauritius?
Provide a succinct answer. 2.58e+07. In the year 1996, what is the difference between the Grants(current US$) of Jamaica and Grants(current US$) of Poland?
Keep it short and to the point. -9.17e+08. In the year 1996, what is the difference between the Grants(current US$) of Jamaica and Grants(current US$) of South Africa?
Offer a very short reply. -1.05e+08. In the year 1996, what is the difference between the Grants(current US$) of Mauritius and Grants(current US$) of Poland?
Keep it short and to the point. -9.43e+08. In the year 1996, what is the difference between the Grants(current US$) in Mauritius and Grants(current US$) in South Africa?
Ensure brevity in your answer.  -1.30e+08. In the year 1996, what is the difference between the Grants(current US$) of Poland and Grants(current US$) of South Africa?
Your answer should be compact. 8.13e+08. In the year 1997, what is the difference between the Grants(current US$) of Jamaica and Grants(current US$) of Mauritius?
Offer a very short reply. 2.65e+07. In the year 1997, what is the difference between the Grants(current US$) of Jamaica and Grants(current US$) of Poland?
Your answer should be very brief. -6.12e+08. In the year 1997, what is the difference between the Grants(current US$) of Jamaica and Grants(current US$) of South Africa?
Provide a short and direct response. -1.59e+08. In the year 1997, what is the difference between the Grants(current US$) in Mauritius and Grants(current US$) in Poland?
Provide a short and direct response. -6.39e+08. In the year 1997, what is the difference between the Grants(current US$) of Mauritius and Grants(current US$) of South Africa?
Your answer should be compact. -1.86e+08. In the year 1997, what is the difference between the Grants(current US$) in Poland and Grants(current US$) in South Africa?
Provide a succinct answer. 4.53e+08. In the year 1998, what is the difference between the Grants(current US$) of Jamaica and Grants(current US$) of Mauritius?
Offer a terse response. 8.03e+07. In the year 1998, what is the difference between the Grants(current US$) in Jamaica and Grants(current US$) in Poland?
Keep it short and to the point. -4.58e+08. In the year 1998, what is the difference between the Grants(current US$) in Jamaica and Grants(current US$) in South Africa?
Give a very brief answer. -1.55e+08. In the year 1998, what is the difference between the Grants(current US$) of Mauritius and Grants(current US$) of Poland?
Provide a succinct answer. -5.39e+08. In the year 1998, what is the difference between the Grants(current US$) of Mauritius and Grants(current US$) of South Africa?
Provide a succinct answer. -2.35e+08. In the year 1998, what is the difference between the Grants(current US$) of Poland and Grants(current US$) of South Africa?
Offer a terse response. 3.04e+08. In the year 1999, what is the difference between the Grants(current US$) in Jamaica and Grants(current US$) in Mauritius?
Offer a terse response. 1.22e+07. In the year 1999, what is the difference between the Grants(current US$) in Jamaica and Grants(current US$) in Poland?
Provide a short and direct response. -6.59e+08. In the year 1999, what is the difference between the Grants(current US$) of Jamaica and Grants(current US$) of South Africa?
Provide a succinct answer. -2.21e+08. In the year 1999, what is the difference between the Grants(current US$) of Mauritius and Grants(current US$) of Poland?
Your answer should be compact. -6.72e+08. In the year 1999, what is the difference between the Grants(current US$) of Mauritius and Grants(current US$) of South Africa?
Your answer should be compact. -2.33e+08. In the year 1999, what is the difference between the Grants(current US$) of Poland and Grants(current US$) of South Africa?
Make the answer very short. 4.39e+08. In the year 2000, what is the difference between the Grants(current US$) in Jamaica and Grants(current US$) in Mauritius?
Make the answer very short. 3.48e+07. In the year 2000, what is the difference between the Grants(current US$) of Jamaica and Grants(current US$) of Poland?
Offer a very short reply. -6.28e+08. In the year 2000, what is the difference between the Grants(current US$) in Jamaica and Grants(current US$) in South Africa?
Make the answer very short. -1.74e+08. In the year 2000, what is the difference between the Grants(current US$) in Mauritius and Grants(current US$) in Poland?
Keep it short and to the point. -6.63e+08. In the year 2000, what is the difference between the Grants(current US$) of Mauritius and Grants(current US$) of South Africa?
Your answer should be compact. -2.09e+08. In the year 2000, what is the difference between the Grants(current US$) in Poland and Grants(current US$) in South Africa?
Offer a terse response. 4.54e+08. What is the ratio of the Grants(current US$) in Jamaica in 1993 to that in 1994?
Ensure brevity in your answer.  2.66. What is the ratio of the Grants(current US$) in Mauritius in 1993 to that in 1994?
Keep it short and to the point. 1.29. What is the ratio of the Grants(current US$) of Poland in 1993 to that in 1994?
Your answer should be compact. 0.54. What is the ratio of the Grants(current US$) of South Africa in 1993 to that in 1994?
Make the answer very short. 0.92. What is the ratio of the Grants(current US$) in Jamaica in 1993 to that in 1995?
Offer a very short reply. 3.82. What is the ratio of the Grants(current US$) in Mauritius in 1993 to that in 1995?
Offer a terse response. 0.66. What is the ratio of the Grants(current US$) in Poland in 1993 to that in 1995?
Provide a succinct answer. 0.27. What is the ratio of the Grants(current US$) of South Africa in 1993 to that in 1995?
Provide a short and direct response. 0.86. What is the ratio of the Grants(current US$) of Jamaica in 1993 to that in 1996?
Offer a very short reply. 6.21. What is the ratio of the Grants(current US$) of Mauritius in 1993 to that in 1996?
Give a very brief answer. 1.17. What is the ratio of the Grants(current US$) of Poland in 1993 to that in 1996?
Your answer should be very brief. 0.95. What is the ratio of the Grants(current US$) of South Africa in 1993 to that in 1996?
Your answer should be very brief. 0.94. What is the ratio of the Grants(current US$) in Jamaica in 1993 to that in 1997?
Your answer should be very brief. 6.03. What is the ratio of the Grants(current US$) of Mauritius in 1993 to that in 1997?
Offer a very short reply. 1.13. What is the ratio of the Grants(current US$) of Poland in 1993 to that in 1997?
Ensure brevity in your answer.  1.4. What is the ratio of the Grants(current US$) of South Africa in 1993 to that in 1997?
Provide a short and direct response. 0.68. What is the ratio of the Grants(current US$) of Jamaica in 1993 to that in 1998?
Your answer should be compact. 2.63. What is the ratio of the Grants(current US$) in Mauritius in 1993 to that in 1998?
Ensure brevity in your answer.  1.32. What is the ratio of the Grants(current US$) of Poland in 1993 to that in 1998?
Offer a very short reply. 1.66. What is the ratio of the Grants(current US$) of South Africa in 1993 to that in 1998?
Give a very brief answer. 0.55. What is the ratio of the Grants(current US$) of Jamaica in 1993 to that in 1999?
Offer a terse response. 10.13. What is the ratio of the Grants(current US$) in Mauritius in 1993 to that in 1999?
Offer a terse response. 1.32. What is the ratio of the Grants(current US$) of Poland in 1993 to that in 1999?
Ensure brevity in your answer.  1.33. What is the ratio of the Grants(current US$) in South Africa in 1993 to that in 1999?
Offer a terse response. 0.55. What is the ratio of the Grants(current US$) in Jamaica in 1993 to that in 2000?
Provide a succinct answer. 5.55. What is the ratio of the Grants(current US$) of Mauritius in 1993 to that in 2000?
Ensure brevity in your answer.  1.76. What is the ratio of the Grants(current US$) in Poland in 1993 to that in 2000?
Your answer should be compact. 1.36. What is the ratio of the Grants(current US$) in South Africa in 1993 to that in 2000?
Offer a very short reply. 0.62. What is the ratio of the Grants(current US$) of Jamaica in 1994 to that in 1995?
Give a very brief answer. 1.43. What is the ratio of the Grants(current US$) of Mauritius in 1994 to that in 1995?
Your response must be concise. 0.51. What is the ratio of the Grants(current US$) of Poland in 1994 to that in 1995?
Make the answer very short. 0.5. What is the ratio of the Grants(current US$) in South Africa in 1994 to that in 1995?
Offer a very short reply. 0.94. What is the ratio of the Grants(current US$) of Jamaica in 1994 to that in 1996?
Your answer should be very brief. 2.33. What is the ratio of the Grants(current US$) in Mauritius in 1994 to that in 1996?
Keep it short and to the point. 0.9. What is the ratio of the Grants(current US$) of Poland in 1994 to that in 1996?
Make the answer very short. 1.77. What is the ratio of the Grants(current US$) of South Africa in 1994 to that in 1996?
Provide a succinct answer. 1.02. What is the ratio of the Grants(current US$) in Jamaica in 1994 to that in 1997?
Offer a terse response. 2.26. What is the ratio of the Grants(current US$) of Mauritius in 1994 to that in 1997?
Keep it short and to the point. 0.88. What is the ratio of the Grants(current US$) of Poland in 1994 to that in 1997?
Give a very brief answer. 2.59. What is the ratio of the Grants(current US$) of South Africa in 1994 to that in 1997?
Your response must be concise. 0.73. What is the ratio of the Grants(current US$) of Jamaica in 1994 to that in 1998?
Provide a short and direct response. 0.99. What is the ratio of the Grants(current US$) of Mauritius in 1994 to that in 1998?
Offer a very short reply. 1.02. What is the ratio of the Grants(current US$) in Poland in 1994 to that in 1998?
Provide a short and direct response. 3.07. What is the ratio of the Grants(current US$) of South Africa in 1994 to that in 1998?
Your answer should be compact. 0.59. What is the ratio of the Grants(current US$) of Jamaica in 1994 to that in 1999?
Offer a terse response. 3.8. What is the ratio of the Grants(current US$) of Mauritius in 1994 to that in 1999?
Your response must be concise. 1.02. What is the ratio of the Grants(current US$) of Poland in 1994 to that in 1999?
Give a very brief answer. 2.47. What is the ratio of the Grants(current US$) of South Africa in 1994 to that in 1999?
Make the answer very short. 0.6. What is the ratio of the Grants(current US$) in Jamaica in 1994 to that in 2000?
Provide a succinct answer. 2.08. What is the ratio of the Grants(current US$) in Mauritius in 1994 to that in 2000?
Your answer should be very brief. 1.36. What is the ratio of the Grants(current US$) of Poland in 1994 to that in 2000?
Provide a short and direct response. 2.51. What is the ratio of the Grants(current US$) in South Africa in 1994 to that in 2000?
Offer a terse response. 0.67. What is the ratio of the Grants(current US$) in Jamaica in 1995 to that in 1996?
Keep it short and to the point. 1.63. What is the ratio of the Grants(current US$) in Mauritius in 1995 to that in 1996?
Your response must be concise. 1.78. What is the ratio of the Grants(current US$) in Poland in 1995 to that in 1996?
Give a very brief answer. 3.56. What is the ratio of the Grants(current US$) of South Africa in 1995 to that in 1996?
Provide a short and direct response. 1.09. What is the ratio of the Grants(current US$) of Jamaica in 1995 to that in 1997?
Keep it short and to the point. 1.58. What is the ratio of the Grants(current US$) in Mauritius in 1995 to that in 1997?
Your response must be concise. 1.73. What is the ratio of the Grants(current US$) of Poland in 1995 to that in 1997?
Provide a short and direct response. 5.23. What is the ratio of the Grants(current US$) of South Africa in 1995 to that in 1997?
Provide a succinct answer. 0.78. What is the ratio of the Grants(current US$) in Jamaica in 1995 to that in 1998?
Keep it short and to the point. 0.69. What is the ratio of the Grants(current US$) of Mauritius in 1995 to that in 1998?
Offer a terse response. 2.01. What is the ratio of the Grants(current US$) of Poland in 1995 to that in 1998?
Make the answer very short. 6.19. What is the ratio of the Grants(current US$) in South Africa in 1995 to that in 1998?
Your response must be concise. 0.63. What is the ratio of the Grants(current US$) of Jamaica in 1995 to that in 1999?
Provide a succinct answer. 2.66. What is the ratio of the Grants(current US$) of Mauritius in 1995 to that in 1999?
Ensure brevity in your answer.  2.01. What is the ratio of the Grants(current US$) in Poland in 1995 to that in 1999?
Give a very brief answer. 4.99. What is the ratio of the Grants(current US$) in South Africa in 1995 to that in 1999?
Your answer should be very brief. 0.64. What is the ratio of the Grants(current US$) in Jamaica in 1995 to that in 2000?
Give a very brief answer. 1.46. What is the ratio of the Grants(current US$) in Mauritius in 1995 to that in 2000?
Ensure brevity in your answer.  2.68. What is the ratio of the Grants(current US$) in Poland in 1995 to that in 2000?
Ensure brevity in your answer.  5.08. What is the ratio of the Grants(current US$) of South Africa in 1995 to that in 2000?
Keep it short and to the point. 0.72. What is the ratio of the Grants(current US$) in Jamaica in 1996 to that in 1997?
Provide a short and direct response. 0.97. What is the ratio of the Grants(current US$) in Mauritius in 1996 to that in 1997?
Make the answer very short. 0.97. What is the ratio of the Grants(current US$) of Poland in 1996 to that in 1997?
Provide a short and direct response. 1.47. What is the ratio of the Grants(current US$) of South Africa in 1996 to that in 1997?
Provide a short and direct response. 0.72. What is the ratio of the Grants(current US$) of Jamaica in 1996 to that in 1998?
Your response must be concise. 0.42. What is the ratio of the Grants(current US$) of Mauritius in 1996 to that in 1998?
Provide a short and direct response. 1.13. What is the ratio of the Grants(current US$) in Poland in 1996 to that in 1998?
Keep it short and to the point. 1.74. What is the ratio of the Grants(current US$) in South Africa in 1996 to that in 1998?
Ensure brevity in your answer.  0.58. What is the ratio of the Grants(current US$) of Jamaica in 1996 to that in 1999?
Keep it short and to the point. 1.63. What is the ratio of the Grants(current US$) in Mauritius in 1996 to that in 1999?
Provide a succinct answer. 1.13. What is the ratio of the Grants(current US$) in Poland in 1996 to that in 1999?
Give a very brief answer. 1.4. What is the ratio of the Grants(current US$) of South Africa in 1996 to that in 1999?
Your answer should be very brief. 0.59. What is the ratio of the Grants(current US$) of Jamaica in 1996 to that in 2000?
Your response must be concise. 0.89. What is the ratio of the Grants(current US$) of Mauritius in 1996 to that in 2000?
Keep it short and to the point. 1.51. What is the ratio of the Grants(current US$) in Poland in 1996 to that in 2000?
Offer a very short reply. 1.42. What is the ratio of the Grants(current US$) of South Africa in 1996 to that in 2000?
Give a very brief answer. 0.66. What is the ratio of the Grants(current US$) of Jamaica in 1997 to that in 1998?
Ensure brevity in your answer.  0.44. What is the ratio of the Grants(current US$) of Mauritius in 1997 to that in 1998?
Make the answer very short. 1.17. What is the ratio of the Grants(current US$) in Poland in 1997 to that in 1998?
Ensure brevity in your answer.  1.18. What is the ratio of the Grants(current US$) in South Africa in 1997 to that in 1998?
Offer a terse response. 0.81. What is the ratio of the Grants(current US$) of Jamaica in 1997 to that in 1999?
Make the answer very short. 1.68. What is the ratio of the Grants(current US$) of Mauritius in 1997 to that in 1999?
Your response must be concise. 1.16. What is the ratio of the Grants(current US$) in Poland in 1997 to that in 1999?
Give a very brief answer. 0.95. What is the ratio of the Grants(current US$) of South Africa in 1997 to that in 1999?
Provide a succinct answer. 0.81. What is the ratio of the Grants(current US$) in Jamaica in 1997 to that in 2000?
Your answer should be compact. 0.92. What is the ratio of the Grants(current US$) in Mauritius in 1997 to that in 2000?
Your response must be concise. 1.55. What is the ratio of the Grants(current US$) in Poland in 1997 to that in 2000?
Ensure brevity in your answer.  0.97. What is the ratio of the Grants(current US$) in South Africa in 1997 to that in 2000?
Give a very brief answer. 0.92. What is the ratio of the Grants(current US$) in Jamaica in 1998 to that in 1999?
Give a very brief answer. 3.85. What is the ratio of the Grants(current US$) of Mauritius in 1998 to that in 1999?
Provide a succinct answer. 1. What is the ratio of the Grants(current US$) of Poland in 1998 to that in 1999?
Offer a very short reply. 0.81. What is the ratio of the Grants(current US$) of South Africa in 1998 to that in 1999?
Ensure brevity in your answer.  1.01. What is the ratio of the Grants(current US$) of Jamaica in 1998 to that in 2000?
Offer a very short reply. 2.11. What is the ratio of the Grants(current US$) in Mauritius in 1998 to that in 2000?
Your answer should be compact. 1.33. What is the ratio of the Grants(current US$) in Poland in 1998 to that in 2000?
Give a very brief answer. 0.82. What is the ratio of the Grants(current US$) in South Africa in 1998 to that in 2000?
Ensure brevity in your answer.  1.13. What is the ratio of the Grants(current US$) of Jamaica in 1999 to that in 2000?
Provide a short and direct response. 0.55. What is the ratio of the Grants(current US$) in Mauritius in 1999 to that in 2000?
Provide a succinct answer. 1.33. What is the ratio of the Grants(current US$) of Poland in 1999 to that in 2000?
Offer a terse response. 1.02. What is the ratio of the Grants(current US$) in South Africa in 1999 to that in 2000?
Provide a succinct answer. 1.12. What is the difference between the highest and the second highest Grants(current US$) in Jamaica?
Give a very brief answer. 1.50e+08. What is the difference between the highest and the second highest Grants(current US$) of Mauritius?
Your response must be concise. 8.08e+06. What is the difference between the highest and the second highest Grants(current US$) of Poland?
Keep it short and to the point. 1.72e+09. What is the difference between the highest and the second highest Grants(current US$) of South Africa?
Ensure brevity in your answer.  1.90e+06. What is the difference between the highest and the lowest Grants(current US$) in Jamaica?
Offer a very short reply. 2.18e+08. What is the difference between the highest and the lowest Grants(current US$) of Mauritius?
Your answer should be compact. 1.47e+07. What is the difference between the highest and the lowest Grants(current US$) in Poland?
Keep it short and to the point. 2.86e+09. What is the difference between the highest and the lowest Grants(current US$) in South Africa?
Make the answer very short. 1.12e+08. 